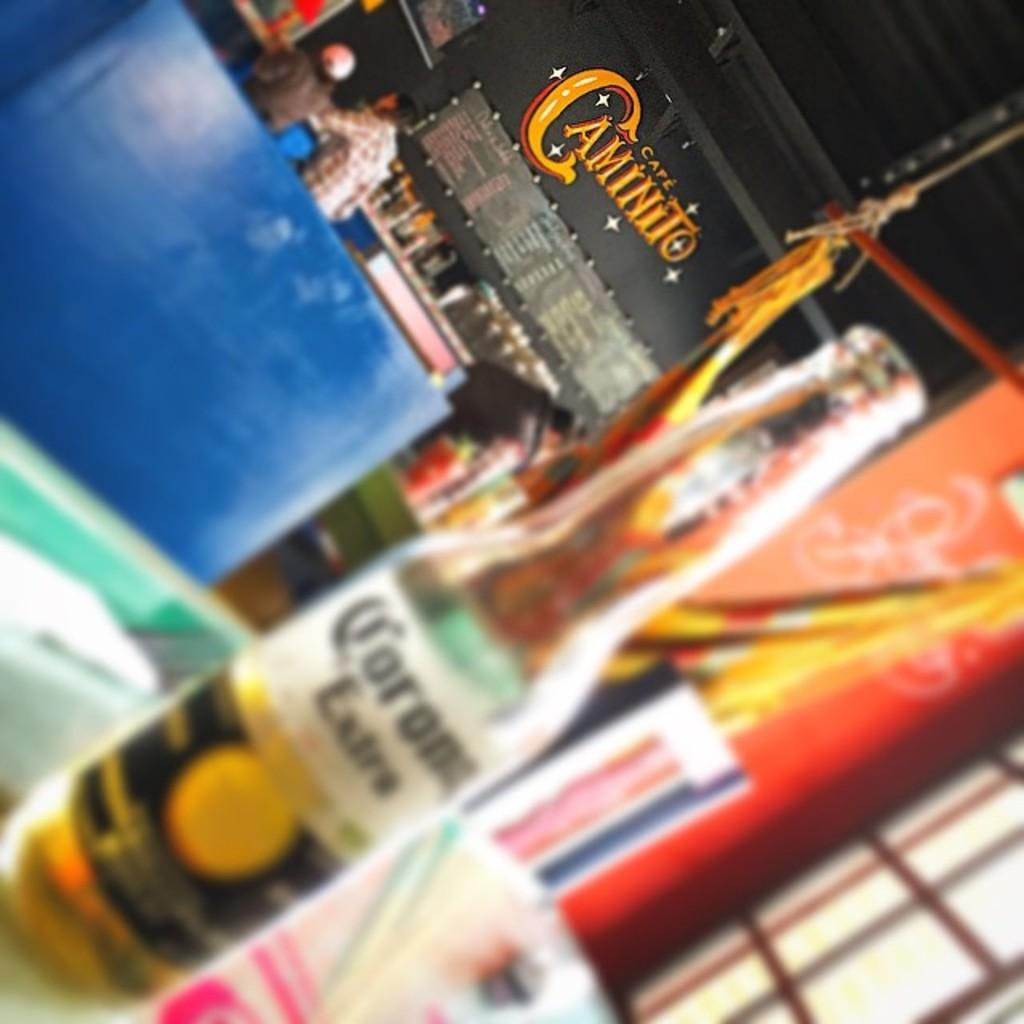<image>
Provide a brief description of the given image. A bottle of Corona Extra is on a table at Cafe Caminito. 